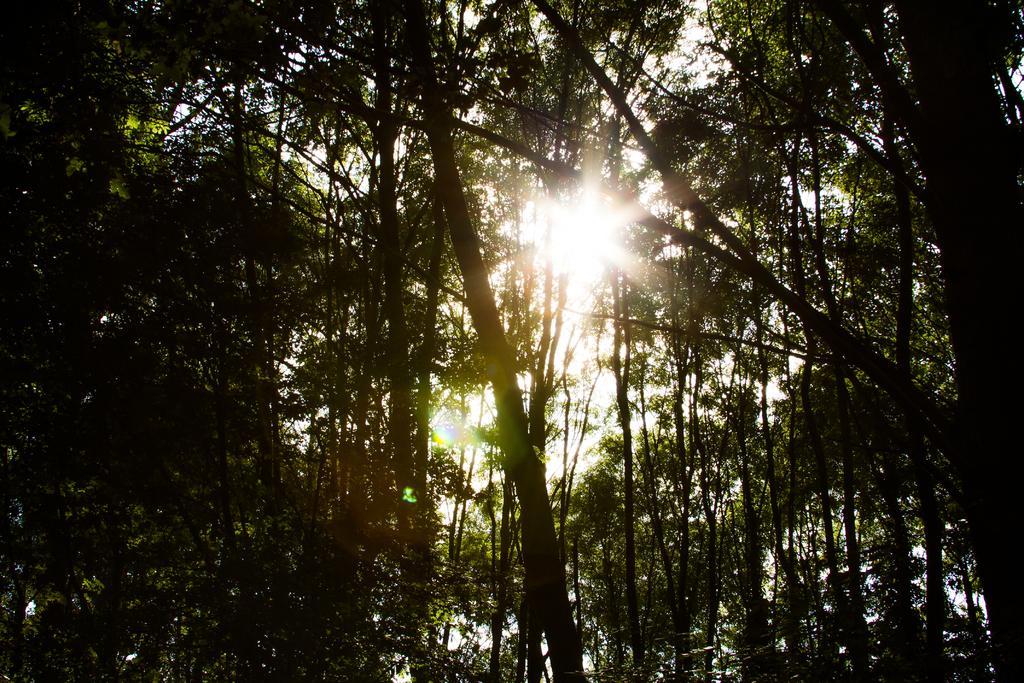Please provide a concise description of this image. This image is taken outdoors. In the background there is the sky and there is sun in the sky. In the middle of the image there are many trees with leaves, stems and branches. 